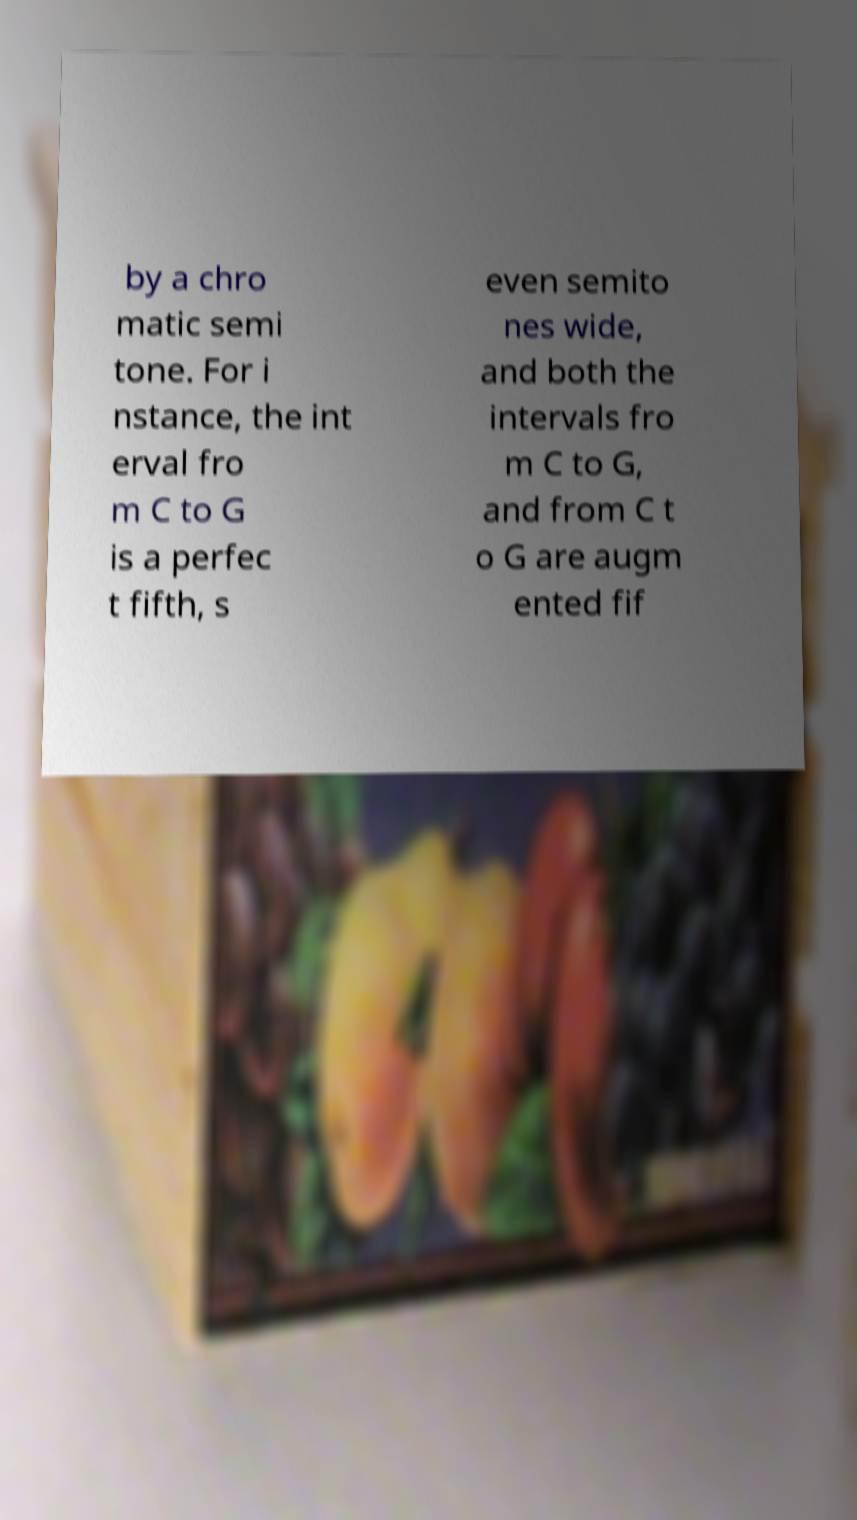There's text embedded in this image that I need extracted. Can you transcribe it verbatim? by a chro matic semi tone. For i nstance, the int erval fro m C to G is a perfec t fifth, s even semito nes wide, and both the intervals fro m C to G, and from C t o G are augm ented fif 